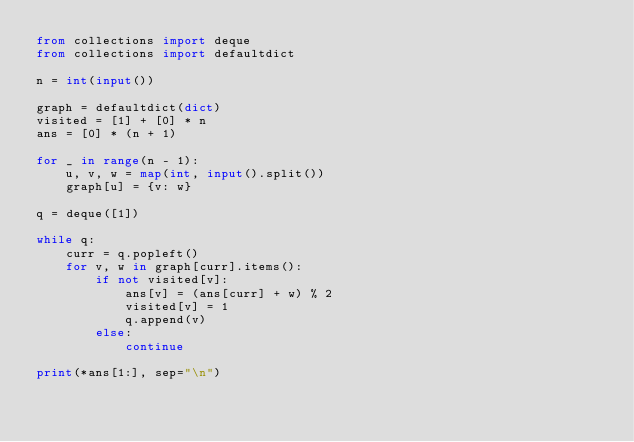<code> <loc_0><loc_0><loc_500><loc_500><_Python_>from collections import deque
from collections import defaultdict

n = int(input())

graph = defaultdict(dict)
visited = [1] + [0] * n
ans = [0] * (n + 1)

for _ in range(n - 1):
    u, v, w = map(int, input().split())
    graph[u] = {v: w}

q = deque([1])

while q:
    curr = q.popleft()
    for v, w in graph[curr].items():
        if not visited[v]:
            ans[v] = (ans[curr] + w) % 2
            visited[v] = 1
            q.append(v)
        else:
            continue

print(*ans[1:], sep="\n")</code> 